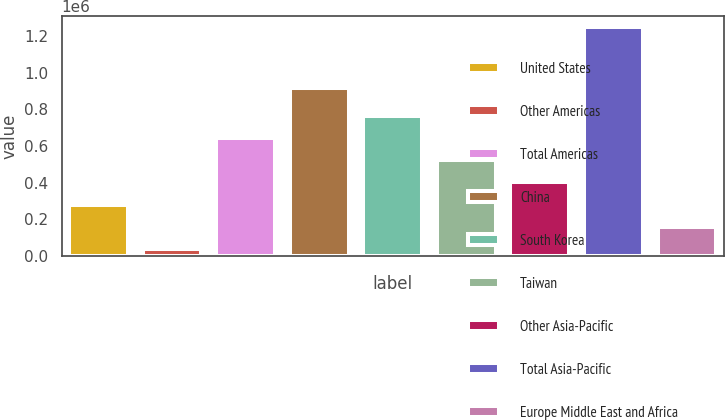<chart> <loc_0><loc_0><loc_500><loc_500><bar_chart><fcel>United States<fcel>Other Americas<fcel>Total Americas<fcel>China<fcel>South Korea<fcel>Taiwan<fcel>Other Asia-Pacific<fcel>Total Asia-Pacific<fcel>Europe Middle East and Africa<nl><fcel>280755<fcel>38863<fcel>643592<fcel>914678<fcel>764538<fcel>522647<fcel>401701<fcel>1.24832e+06<fcel>159809<nl></chart> 